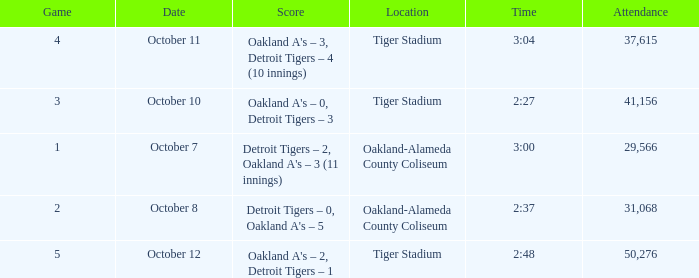Can you parse all the data within this table? {'header': ['Game', 'Date', 'Score', 'Location', 'Time', 'Attendance'], 'rows': [['4', 'October 11', "Oakland A's – 3, Detroit Tigers – 4 (10 innings)", 'Tiger Stadium', '3:04', '37,615'], ['3', 'October 10', "Oakland A's – 0, Detroit Tigers – 3", 'Tiger Stadium', '2:27', '41,156'], ['1', 'October 7', "Detroit Tigers – 2, Oakland A's – 3 (11 innings)", 'Oakland-Alameda County Coliseum', '3:00', '29,566'], ['2', 'October 8', "Detroit Tigers – 0, Oakland A's – 5", 'Oakland-Alameda County Coliseum', '2:37', '31,068'], ['5', 'October 12', "Oakland A's – 2, Detroit Tigers – 1", 'Tiger Stadium', '2:48', '50,276']]} What is the number of people in attendance at Oakland-Alameda County Coliseum, and game is 2? 31068.0. 